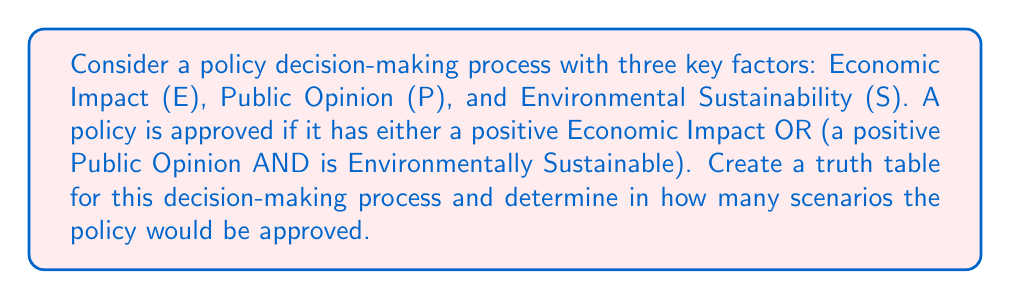Give your solution to this math problem. Let's approach this step-by-step:

1) First, we need to identify our variables:
   E: Economic Impact (1 = positive, 0 = negative)
   P: Public Opinion (1 = positive, 0 = negative)
   S: Environmental Sustainability (1 = sustainable, 0 = not sustainable)

2) The logical expression for policy approval can be written as:
   $$ A = E + (P \cdot S) $$
   Where A is Approval, + represents OR, and · represents AND.

3) Now, let's create the truth table:

   | E | P | S | P·S | E + (P·S) |
   |---|---|---|-----|-----------|
   | 0 | 0 | 0 |  0  |     0     |
   | 0 | 0 | 1 |  0  |     0     |
   | 0 | 1 | 0 |  0  |     0     |
   | 0 | 1 | 1 |  1  |     1     |
   | 1 | 0 | 0 |  0  |     1     |
   | 1 | 0 | 1 |  0  |     1     |
   | 1 | 1 | 0 |  0  |     1     |
   | 1 | 1 | 1 |  1  |     1     |

4) To determine in how many scenarios the policy would be approved, we count the number of 1's in the final column (E + (P·S)).

5) There are 5 scenarios where the policy would be approved:
   - When E = 0, P = 1, S = 1
   - When E = 1, regardless of P and S (4 scenarios)

Therefore, the policy would be approved in 5 out of 8 possible scenarios.
Answer: 5 scenarios 